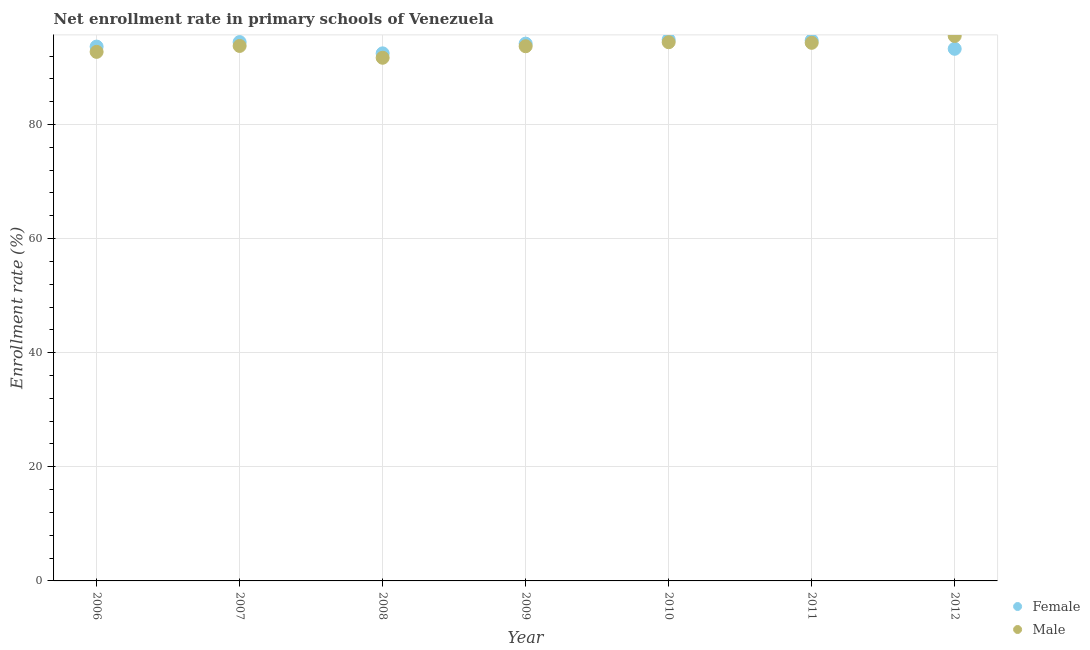What is the enrollment rate of female students in 2009?
Your response must be concise. 94.17. Across all years, what is the maximum enrollment rate of female students?
Provide a succinct answer. 94.86. Across all years, what is the minimum enrollment rate of female students?
Ensure brevity in your answer.  92.47. In which year was the enrollment rate of female students maximum?
Provide a short and direct response. 2010. What is the total enrollment rate of male students in the graph?
Provide a short and direct response. 656.14. What is the difference between the enrollment rate of male students in 2007 and that in 2012?
Provide a succinct answer. -1.75. What is the difference between the enrollment rate of male students in 2011 and the enrollment rate of female students in 2010?
Give a very brief answer. -0.55. What is the average enrollment rate of female students per year?
Your response must be concise. 93.94. In the year 2011, what is the difference between the enrollment rate of male students and enrollment rate of female students?
Keep it short and to the point. -0.43. What is the ratio of the enrollment rate of female students in 2010 to that in 2012?
Make the answer very short. 1.02. What is the difference between the highest and the second highest enrollment rate of male students?
Your answer should be compact. 1.1. What is the difference between the highest and the lowest enrollment rate of female students?
Ensure brevity in your answer.  2.4. Does the enrollment rate of female students monotonically increase over the years?
Your response must be concise. No. Is the enrollment rate of female students strictly greater than the enrollment rate of male students over the years?
Your response must be concise. No. What is the difference between two consecutive major ticks on the Y-axis?
Keep it short and to the point. 20. Are the values on the major ticks of Y-axis written in scientific E-notation?
Your answer should be very brief. No. Does the graph contain any zero values?
Your answer should be compact. No. Does the graph contain grids?
Make the answer very short. Yes. Where does the legend appear in the graph?
Make the answer very short. Bottom right. How many legend labels are there?
Ensure brevity in your answer.  2. What is the title of the graph?
Offer a terse response. Net enrollment rate in primary schools of Venezuela. What is the label or title of the X-axis?
Give a very brief answer. Year. What is the label or title of the Y-axis?
Your answer should be very brief. Enrollment rate (%). What is the Enrollment rate (%) in Female in 2006?
Your answer should be very brief. 93.65. What is the Enrollment rate (%) in Male in 2006?
Make the answer very short. 92.72. What is the Enrollment rate (%) in Female in 2007?
Your response must be concise. 94.44. What is the Enrollment rate (%) of Male in 2007?
Offer a terse response. 93.76. What is the Enrollment rate (%) in Female in 2008?
Offer a very short reply. 92.47. What is the Enrollment rate (%) in Male in 2008?
Make the answer very short. 91.69. What is the Enrollment rate (%) of Female in 2009?
Give a very brief answer. 94.17. What is the Enrollment rate (%) in Male in 2009?
Your answer should be compact. 93.71. What is the Enrollment rate (%) of Female in 2010?
Keep it short and to the point. 94.86. What is the Enrollment rate (%) in Male in 2010?
Offer a very short reply. 94.42. What is the Enrollment rate (%) of Female in 2011?
Keep it short and to the point. 94.74. What is the Enrollment rate (%) in Male in 2011?
Give a very brief answer. 94.31. What is the Enrollment rate (%) of Female in 2012?
Your response must be concise. 93.26. What is the Enrollment rate (%) in Male in 2012?
Your answer should be very brief. 95.51. Across all years, what is the maximum Enrollment rate (%) of Female?
Offer a terse response. 94.86. Across all years, what is the maximum Enrollment rate (%) of Male?
Make the answer very short. 95.51. Across all years, what is the minimum Enrollment rate (%) of Female?
Give a very brief answer. 92.47. Across all years, what is the minimum Enrollment rate (%) of Male?
Make the answer very short. 91.69. What is the total Enrollment rate (%) in Female in the graph?
Offer a terse response. 657.6. What is the total Enrollment rate (%) in Male in the graph?
Provide a short and direct response. 656.14. What is the difference between the Enrollment rate (%) of Female in 2006 and that in 2007?
Make the answer very short. -0.79. What is the difference between the Enrollment rate (%) in Male in 2006 and that in 2007?
Make the answer very short. -1.04. What is the difference between the Enrollment rate (%) of Female in 2006 and that in 2008?
Your answer should be very brief. 1.18. What is the difference between the Enrollment rate (%) in Male in 2006 and that in 2008?
Your response must be concise. 1.03. What is the difference between the Enrollment rate (%) of Female in 2006 and that in 2009?
Provide a succinct answer. -0.52. What is the difference between the Enrollment rate (%) of Male in 2006 and that in 2009?
Keep it short and to the point. -0.99. What is the difference between the Enrollment rate (%) of Female in 2006 and that in 2010?
Your answer should be compact. -1.21. What is the difference between the Enrollment rate (%) in Male in 2006 and that in 2010?
Ensure brevity in your answer.  -1.69. What is the difference between the Enrollment rate (%) in Female in 2006 and that in 2011?
Your response must be concise. -1.09. What is the difference between the Enrollment rate (%) in Male in 2006 and that in 2011?
Your response must be concise. -1.59. What is the difference between the Enrollment rate (%) of Female in 2006 and that in 2012?
Offer a very short reply. 0.39. What is the difference between the Enrollment rate (%) of Male in 2006 and that in 2012?
Give a very brief answer. -2.79. What is the difference between the Enrollment rate (%) of Female in 2007 and that in 2008?
Keep it short and to the point. 1.98. What is the difference between the Enrollment rate (%) in Male in 2007 and that in 2008?
Make the answer very short. 2.07. What is the difference between the Enrollment rate (%) of Female in 2007 and that in 2009?
Your response must be concise. 0.27. What is the difference between the Enrollment rate (%) in Male in 2007 and that in 2009?
Give a very brief answer. 0.05. What is the difference between the Enrollment rate (%) in Female in 2007 and that in 2010?
Provide a succinct answer. -0.42. What is the difference between the Enrollment rate (%) in Male in 2007 and that in 2010?
Give a very brief answer. -0.65. What is the difference between the Enrollment rate (%) in Female in 2007 and that in 2011?
Your answer should be compact. -0.3. What is the difference between the Enrollment rate (%) in Male in 2007 and that in 2011?
Your answer should be very brief. -0.55. What is the difference between the Enrollment rate (%) of Female in 2007 and that in 2012?
Offer a very short reply. 1.18. What is the difference between the Enrollment rate (%) of Male in 2007 and that in 2012?
Make the answer very short. -1.75. What is the difference between the Enrollment rate (%) of Female in 2008 and that in 2009?
Offer a very short reply. -1.7. What is the difference between the Enrollment rate (%) in Male in 2008 and that in 2009?
Your answer should be compact. -2.02. What is the difference between the Enrollment rate (%) of Female in 2008 and that in 2010?
Ensure brevity in your answer.  -2.4. What is the difference between the Enrollment rate (%) in Male in 2008 and that in 2010?
Offer a very short reply. -2.72. What is the difference between the Enrollment rate (%) in Female in 2008 and that in 2011?
Offer a terse response. -2.28. What is the difference between the Enrollment rate (%) of Male in 2008 and that in 2011?
Keep it short and to the point. -2.62. What is the difference between the Enrollment rate (%) of Female in 2008 and that in 2012?
Your answer should be very brief. -0.8. What is the difference between the Enrollment rate (%) of Male in 2008 and that in 2012?
Ensure brevity in your answer.  -3.82. What is the difference between the Enrollment rate (%) in Female in 2009 and that in 2010?
Make the answer very short. -0.7. What is the difference between the Enrollment rate (%) of Male in 2009 and that in 2010?
Offer a very short reply. -0.71. What is the difference between the Enrollment rate (%) in Female in 2009 and that in 2011?
Your response must be concise. -0.58. What is the difference between the Enrollment rate (%) of Female in 2009 and that in 2012?
Keep it short and to the point. 0.9. What is the difference between the Enrollment rate (%) of Male in 2009 and that in 2012?
Offer a very short reply. -1.8. What is the difference between the Enrollment rate (%) of Female in 2010 and that in 2011?
Keep it short and to the point. 0.12. What is the difference between the Enrollment rate (%) of Male in 2010 and that in 2011?
Keep it short and to the point. 0.11. What is the difference between the Enrollment rate (%) in Female in 2010 and that in 2012?
Your answer should be very brief. 1.6. What is the difference between the Enrollment rate (%) of Male in 2010 and that in 2012?
Provide a short and direct response. -1.1. What is the difference between the Enrollment rate (%) of Female in 2011 and that in 2012?
Provide a succinct answer. 1.48. What is the difference between the Enrollment rate (%) of Male in 2011 and that in 2012?
Your answer should be compact. -1.2. What is the difference between the Enrollment rate (%) in Female in 2006 and the Enrollment rate (%) in Male in 2007?
Make the answer very short. -0.12. What is the difference between the Enrollment rate (%) of Female in 2006 and the Enrollment rate (%) of Male in 2008?
Offer a terse response. 1.96. What is the difference between the Enrollment rate (%) in Female in 2006 and the Enrollment rate (%) in Male in 2009?
Your response must be concise. -0.06. What is the difference between the Enrollment rate (%) of Female in 2006 and the Enrollment rate (%) of Male in 2010?
Keep it short and to the point. -0.77. What is the difference between the Enrollment rate (%) in Female in 2006 and the Enrollment rate (%) in Male in 2011?
Make the answer very short. -0.66. What is the difference between the Enrollment rate (%) in Female in 2006 and the Enrollment rate (%) in Male in 2012?
Keep it short and to the point. -1.86. What is the difference between the Enrollment rate (%) in Female in 2007 and the Enrollment rate (%) in Male in 2008?
Offer a terse response. 2.75. What is the difference between the Enrollment rate (%) in Female in 2007 and the Enrollment rate (%) in Male in 2009?
Give a very brief answer. 0.73. What is the difference between the Enrollment rate (%) in Female in 2007 and the Enrollment rate (%) in Male in 2010?
Make the answer very short. 0.02. What is the difference between the Enrollment rate (%) of Female in 2007 and the Enrollment rate (%) of Male in 2011?
Provide a short and direct response. 0.13. What is the difference between the Enrollment rate (%) of Female in 2007 and the Enrollment rate (%) of Male in 2012?
Give a very brief answer. -1.07. What is the difference between the Enrollment rate (%) of Female in 2008 and the Enrollment rate (%) of Male in 2009?
Provide a succinct answer. -1.25. What is the difference between the Enrollment rate (%) in Female in 2008 and the Enrollment rate (%) in Male in 2010?
Provide a succinct answer. -1.95. What is the difference between the Enrollment rate (%) in Female in 2008 and the Enrollment rate (%) in Male in 2011?
Offer a very short reply. -1.85. What is the difference between the Enrollment rate (%) in Female in 2008 and the Enrollment rate (%) in Male in 2012?
Ensure brevity in your answer.  -3.05. What is the difference between the Enrollment rate (%) of Female in 2009 and the Enrollment rate (%) of Male in 2010?
Give a very brief answer. -0.25. What is the difference between the Enrollment rate (%) of Female in 2009 and the Enrollment rate (%) of Male in 2011?
Give a very brief answer. -0.14. What is the difference between the Enrollment rate (%) of Female in 2009 and the Enrollment rate (%) of Male in 2012?
Provide a short and direct response. -1.34. What is the difference between the Enrollment rate (%) of Female in 2010 and the Enrollment rate (%) of Male in 2011?
Provide a short and direct response. 0.55. What is the difference between the Enrollment rate (%) of Female in 2010 and the Enrollment rate (%) of Male in 2012?
Offer a terse response. -0.65. What is the difference between the Enrollment rate (%) in Female in 2011 and the Enrollment rate (%) in Male in 2012?
Your response must be concise. -0.77. What is the average Enrollment rate (%) of Female per year?
Your answer should be compact. 93.94. What is the average Enrollment rate (%) of Male per year?
Offer a terse response. 93.73. In the year 2006, what is the difference between the Enrollment rate (%) of Female and Enrollment rate (%) of Male?
Offer a terse response. 0.93. In the year 2007, what is the difference between the Enrollment rate (%) in Female and Enrollment rate (%) in Male?
Your answer should be very brief. 0.68. In the year 2008, what is the difference between the Enrollment rate (%) of Female and Enrollment rate (%) of Male?
Give a very brief answer. 0.77. In the year 2009, what is the difference between the Enrollment rate (%) of Female and Enrollment rate (%) of Male?
Offer a very short reply. 0.46. In the year 2010, what is the difference between the Enrollment rate (%) of Female and Enrollment rate (%) of Male?
Your answer should be compact. 0.45. In the year 2011, what is the difference between the Enrollment rate (%) in Female and Enrollment rate (%) in Male?
Provide a succinct answer. 0.43. In the year 2012, what is the difference between the Enrollment rate (%) of Female and Enrollment rate (%) of Male?
Your answer should be very brief. -2.25. What is the ratio of the Enrollment rate (%) of Female in 2006 to that in 2007?
Keep it short and to the point. 0.99. What is the ratio of the Enrollment rate (%) of Male in 2006 to that in 2007?
Provide a succinct answer. 0.99. What is the ratio of the Enrollment rate (%) of Female in 2006 to that in 2008?
Your answer should be very brief. 1.01. What is the ratio of the Enrollment rate (%) of Male in 2006 to that in 2008?
Your answer should be very brief. 1.01. What is the ratio of the Enrollment rate (%) in Female in 2006 to that in 2009?
Your answer should be very brief. 0.99. What is the ratio of the Enrollment rate (%) of Female in 2006 to that in 2010?
Your response must be concise. 0.99. What is the ratio of the Enrollment rate (%) of Male in 2006 to that in 2010?
Keep it short and to the point. 0.98. What is the ratio of the Enrollment rate (%) in Female in 2006 to that in 2011?
Your answer should be compact. 0.99. What is the ratio of the Enrollment rate (%) of Male in 2006 to that in 2011?
Ensure brevity in your answer.  0.98. What is the ratio of the Enrollment rate (%) of Male in 2006 to that in 2012?
Ensure brevity in your answer.  0.97. What is the ratio of the Enrollment rate (%) in Female in 2007 to that in 2008?
Your answer should be very brief. 1.02. What is the ratio of the Enrollment rate (%) of Male in 2007 to that in 2008?
Your answer should be very brief. 1.02. What is the ratio of the Enrollment rate (%) in Female in 2007 to that in 2010?
Your response must be concise. 1. What is the ratio of the Enrollment rate (%) of Male in 2007 to that in 2010?
Make the answer very short. 0.99. What is the ratio of the Enrollment rate (%) of Female in 2007 to that in 2012?
Ensure brevity in your answer.  1.01. What is the ratio of the Enrollment rate (%) of Male in 2007 to that in 2012?
Your answer should be very brief. 0.98. What is the ratio of the Enrollment rate (%) of Female in 2008 to that in 2009?
Your answer should be very brief. 0.98. What is the ratio of the Enrollment rate (%) in Male in 2008 to that in 2009?
Your answer should be compact. 0.98. What is the ratio of the Enrollment rate (%) of Female in 2008 to that in 2010?
Make the answer very short. 0.97. What is the ratio of the Enrollment rate (%) in Male in 2008 to that in 2010?
Your answer should be compact. 0.97. What is the ratio of the Enrollment rate (%) in Male in 2008 to that in 2011?
Keep it short and to the point. 0.97. What is the ratio of the Enrollment rate (%) in Female in 2008 to that in 2012?
Offer a very short reply. 0.99. What is the ratio of the Enrollment rate (%) in Male in 2008 to that in 2012?
Ensure brevity in your answer.  0.96. What is the ratio of the Enrollment rate (%) in Male in 2009 to that in 2010?
Provide a short and direct response. 0.99. What is the ratio of the Enrollment rate (%) in Female in 2009 to that in 2011?
Make the answer very short. 0.99. What is the ratio of the Enrollment rate (%) in Male in 2009 to that in 2011?
Ensure brevity in your answer.  0.99. What is the ratio of the Enrollment rate (%) in Female in 2009 to that in 2012?
Ensure brevity in your answer.  1.01. What is the ratio of the Enrollment rate (%) of Male in 2009 to that in 2012?
Your answer should be very brief. 0.98. What is the ratio of the Enrollment rate (%) in Female in 2010 to that in 2011?
Provide a succinct answer. 1. What is the ratio of the Enrollment rate (%) in Male in 2010 to that in 2011?
Make the answer very short. 1. What is the ratio of the Enrollment rate (%) of Female in 2010 to that in 2012?
Provide a succinct answer. 1.02. What is the ratio of the Enrollment rate (%) in Male in 2010 to that in 2012?
Keep it short and to the point. 0.99. What is the ratio of the Enrollment rate (%) of Female in 2011 to that in 2012?
Keep it short and to the point. 1.02. What is the ratio of the Enrollment rate (%) of Male in 2011 to that in 2012?
Offer a very short reply. 0.99. What is the difference between the highest and the second highest Enrollment rate (%) of Female?
Your answer should be very brief. 0.12. What is the difference between the highest and the second highest Enrollment rate (%) in Male?
Keep it short and to the point. 1.1. What is the difference between the highest and the lowest Enrollment rate (%) in Female?
Your answer should be compact. 2.4. What is the difference between the highest and the lowest Enrollment rate (%) of Male?
Keep it short and to the point. 3.82. 